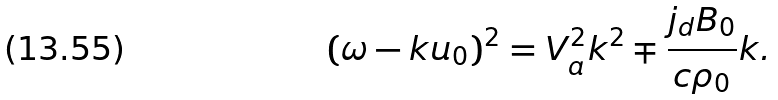Convert formula to latex. <formula><loc_0><loc_0><loc_500><loc_500>( \omega - { k u } _ { 0 } ) ^ { 2 } = V ^ { 2 } _ { a } k ^ { 2 } \mp \frac { j _ { d } B _ { 0 } } { c \rho _ { 0 } } k .</formula> 